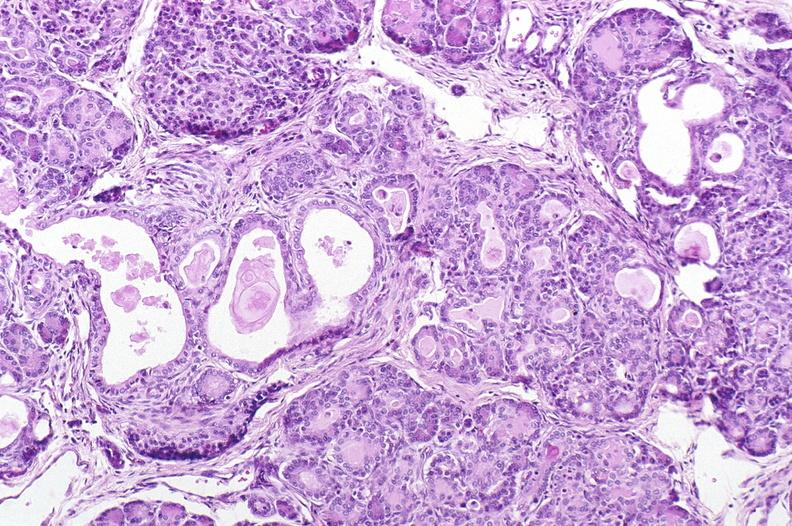what does this image show?
Answer the question using a single word or phrase. Cystic fibrosis 